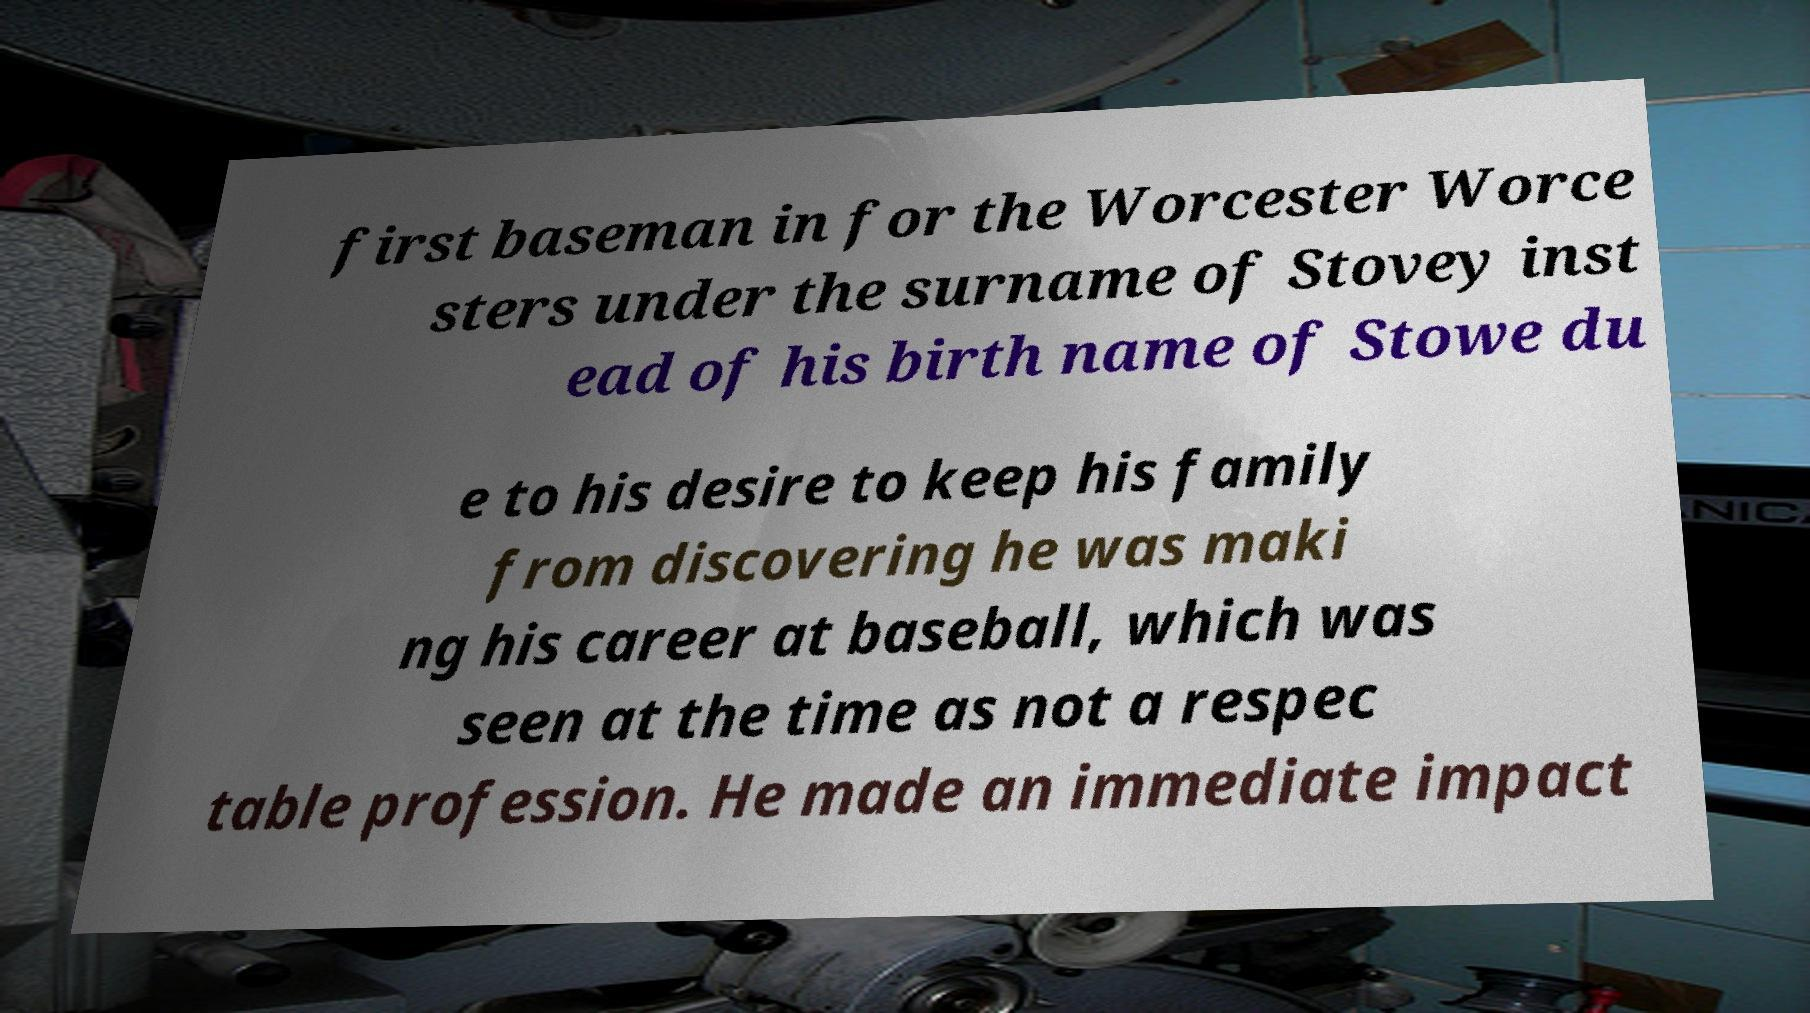Please read and relay the text visible in this image. What does it say? first baseman in for the Worcester Worce sters under the surname of Stovey inst ead of his birth name of Stowe du e to his desire to keep his family from discovering he was maki ng his career at baseball, which was seen at the time as not a respec table profession. He made an immediate impact 